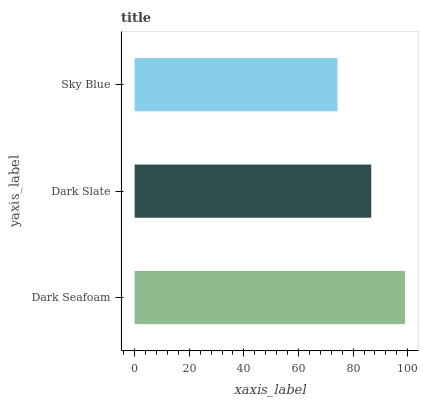Is Sky Blue the minimum?
Answer yes or no. Yes. Is Dark Seafoam the maximum?
Answer yes or no. Yes. Is Dark Slate the minimum?
Answer yes or no. No. Is Dark Slate the maximum?
Answer yes or no. No. Is Dark Seafoam greater than Dark Slate?
Answer yes or no. Yes. Is Dark Slate less than Dark Seafoam?
Answer yes or no. Yes. Is Dark Slate greater than Dark Seafoam?
Answer yes or no. No. Is Dark Seafoam less than Dark Slate?
Answer yes or no. No. Is Dark Slate the high median?
Answer yes or no. Yes. Is Dark Slate the low median?
Answer yes or no. Yes. Is Sky Blue the high median?
Answer yes or no. No. Is Sky Blue the low median?
Answer yes or no. No. 